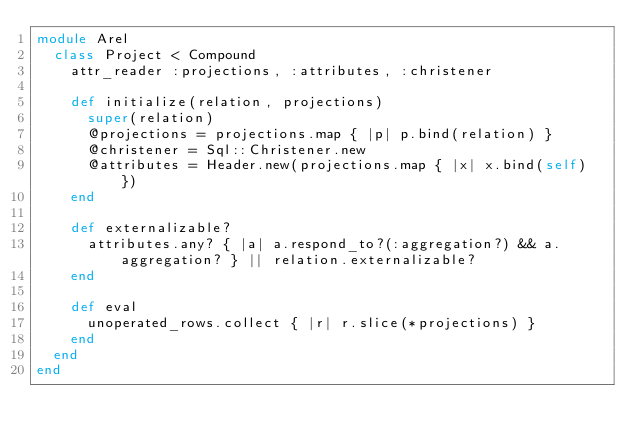Convert code to text. <code><loc_0><loc_0><loc_500><loc_500><_Ruby_>module Arel
  class Project < Compound
    attr_reader :projections, :attributes, :christener

    def initialize(relation, projections)
      super(relation)
      @projections = projections.map { |p| p.bind(relation) }
      @christener = Sql::Christener.new
      @attributes = Header.new(projections.map { |x| x.bind(self) })
    end

    def externalizable?
      attributes.any? { |a| a.respond_to?(:aggregation?) && a.aggregation? } || relation.externalizable?
    end

    def eval
      unoperated_rows.collect { |r| r.slice(*projections) }
    end
  end
end
</code> 